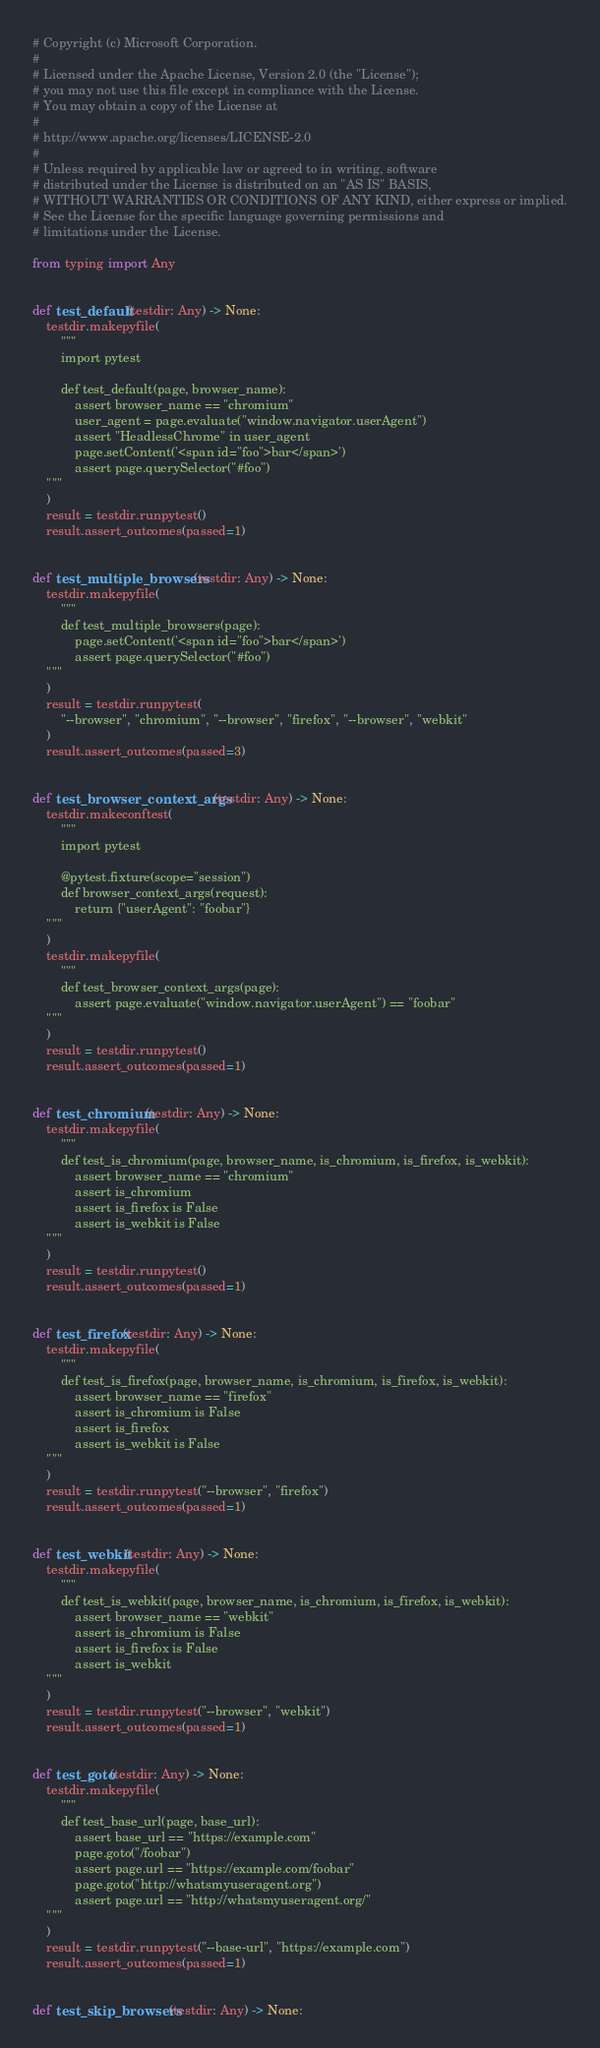<code> <loc_0><loc_0><loc_500><loc_500><_Python_># Copyright (c) Microsoft Corporation.
#
# Licensed under the Apache License, Version 2.0 (the "License");
# you may not use this file except in compliance with the License.
# You may obtain a copy of the License at
#
# http://www.apache.org/licenses/LICENSE-2.0
#
# Unless required by applicable law or agreed to in writing, software
# distributed under the License is distributed on an "AS IS" BASIS,
# WITHOUT WARRANTIES OR CONDITIONS OF ANY KIND, either express or implied.
# See the License for the specific language governing permissions and
# limitations under the License.

from typing import Any


def test_default(testdir: Any) -> None:
    testdir.makepyfile(
        """
        import pytest

        def test_default(page, browser_name):
            assert browser_name == "chromium"
            user_agent = page.evaluate("window.navigator.userAgent")
            assert "HeadlessChrome" in user_agent
            page.setContent('<span id="foo">bar</span>')
            assert page.querySelector("#foo")
    """
    )
    result = testdir.runpytest()
    result.assert_outcomes(passed=1)


def test_multiple_browsers(testdir: Any) -> None:
    testdir.makepyfile(
        """
        def test_multiple_browsers(page):
            page.setContent('<span id="foo">bar</span>')
            assert page.querySelector("#foo")
    """
    )
    result = testdir.runpytest(
        "--browser", "chromium", "--browser", "firefox", "--browser", "webkit"
    )
    result.assert_outcomes(passed=3)


def test_browser_context_args(testdir: Any) -> None:
    testdir.makeconftest(
        """
        import pytest

        @pytest.fixture(scope="session")
        def browser_context_args(request):
            return {"userAgent": "foobar"}
    """
    )
    testdir.makepyfile(
        """
        def test_browser_context_args(page):
            assert page.evaluate("window.navigator.userAgent") == "foobar"
    """
    )
    result = testdir.runpytest()
    result.assert_outcomes(passed=1)


def test_chromium(testdir: Any) -> None:
    testdir.makepyfile(
        """
        def test_is_chromium(page, browser_name, is_chromium, is_firefox, is_webkit):
            assert browser_name == "chromium"
            assert is_chromium
            assert is_firefox is False
            assert is_webkit is False
    """
    )
    result = testdir.runpytest()
    result.assert_outcomes(passed=1)


def test_firefox(testdir: Any) -> None:
    testdir.makepyfile(
        """
        def test_is_firefox(page, browser_name, is_chromium, is_firefox, is_webkit):
            assert browser_name == "firefox"
            assert is_chromium is False
            assert is_firefox
            assert is_webkit is False
    """
    )
    result = testdir.runpytest("--browser", "firefox")
    result.assert_outcomes(passed=1)


def test_webkit(testdir: Any) -> None:
    testdir.makepyfile(
        """
        def test_is_webkit(page, browser_name, is_chromium, is_firefox, is_webkit):
            assert browser_name == "webkit"
            assert is_chromium is False
            assert is_firefox is False
            assert is_webkit
    """
    )
    result = testdir.runpytest("--browser", "webkit")
    result.assert_outcomes(passed=1)


def test_goto(testdir: Any) -> None:
    testdir.makepyfile(
        """
        def test_base_url(page, base_url):
            assert base_url == "https://example.com"
            page.goto("/foobar")
            assert page.url == "https://example.com/foobar"
            page.goto("http://whatsmyuseragent.org")
            assert page.url == "http://whatsmyuseragent.org/"
    """
    )
    result = testdir.runpytest("--base-url", "https://example.com")
    result.assert_outcomes(passed=1)


def test_skip_browsers(testdir: Any) -> None:</code> 